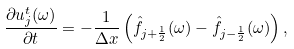<formula> <loc_0><loc_0><loc_500><loc_500>\frac { \partial u ^ { t } _ { j } ( \omega ) } { \partial t } = - \frac { 1 } { \Delta x } \left ( \hat { f } _ { j + \frac { 1 } { 2 } } ( \omega ) - \hat { f } _ { j - \frac { 1 } { 2 } } ( \omega ) \right ) ,</formula> 